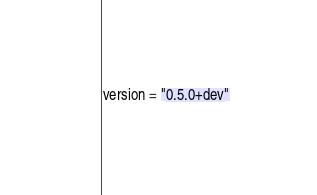Convert code to text. <code><loc_0><loc_0><loc_500><loc_500><_Python_>version = "0.5.0+dev"
</code> 